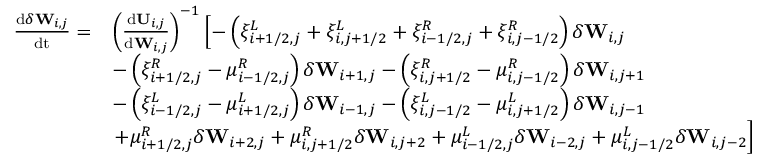Convert formula to latex. <formula><loc_0><loc_0><loc_500><loc_500>\begin{array} { r l } { \frac { d \delta W _ { i , j } } { d t } = } & { \left ( \frac { d U _ { i , j } } { d { W _ { i , j } } } \right ) ^ { - 1 } \left [ - \left ( \xi _ { i + 1 / 2 , j } ^ { L } + \xi _ { i , j + 1 / 2 } ^ { L } + \xi _ { i - 1 / 2 , j } ^ { R } + \xi _ { i , j - 1 / 2 } ^ { R } \right ) \delta W _ { i , j } } \\ & { - \left ( \xi _ { i + 1 / 2 , j } ^ { R } - \mu _ { i - 1 / 2 , j } ^ { R } \right ) \delta W _ { i + 1 , j } - \left ( \xi _ { i , j + 1 / 2 } ^ { R } - \mu _ { i , j - 1 / 2 } ^ { R } \right ) \delta W _ { i , j + 1 } } \\ & { - \left ( \xi _ { i - 1 / 2 , j } ^ { L } - \mu _ { i + 1 / 2 , j } ^ { L } \right ) \delta W _ { i - 1 , j } - \left ( \xi _ { i , j - 1 / 2 } ^ { L } - \mu _ { i , j + 1 / 2 } ^ { L } \right ) \delta W _ { i , j - 1 } } \\ & { + \mu _ { i + 1 / 2 , j } ^ { R } \delta W _ { i + 2 , j } + \mu _ { i , j + 1 / 2 } ^ { R } \delta W _ { i , j + 2 } + \mu _ { i - 1 / 2 , j } ^ { L } \delta W _ { i - 2 , j } + \mu _ { i , j - 1 / 2 } ^ { L } \delta W _ { i , j - 2 } \right ] } \end{array}</formula> 